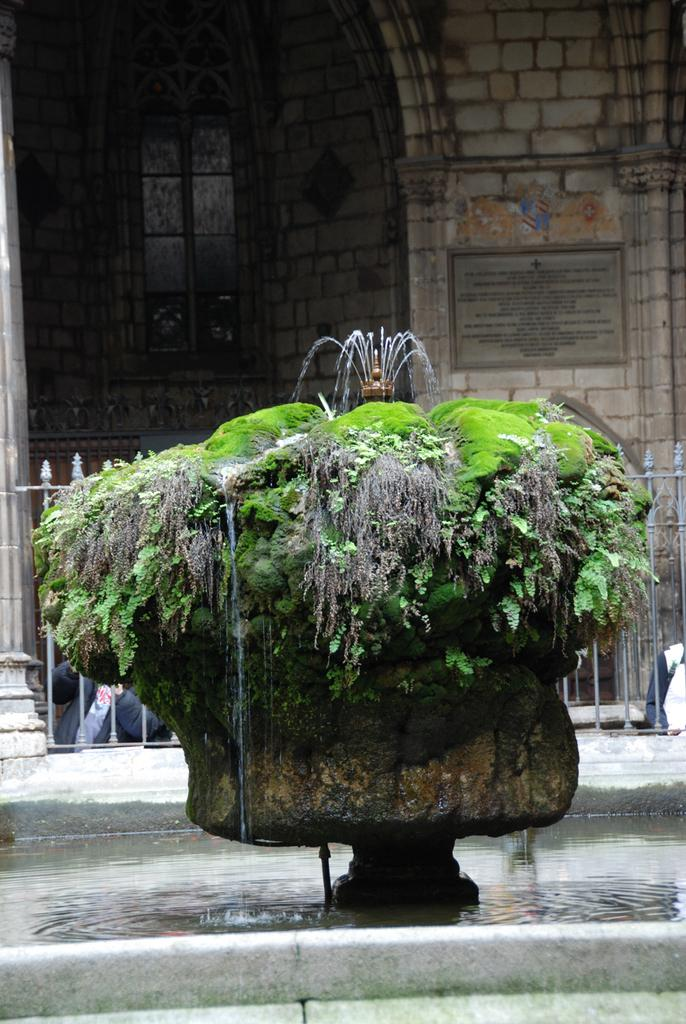What is the main feature of the image? There is water in the image. What is located within the water? There is a fountain in the water. What other objects can be seen in the image? There is a fence and a board in the image. Who or what is present in the image? There are two persons in the image. What can be seen in the background of the image? There is a building in the background of the image. How many ants are crawling on the board in the image? There are no ants present in the image. What letters are written on the fence in the image? There are no letters visible on the fence in the image. 